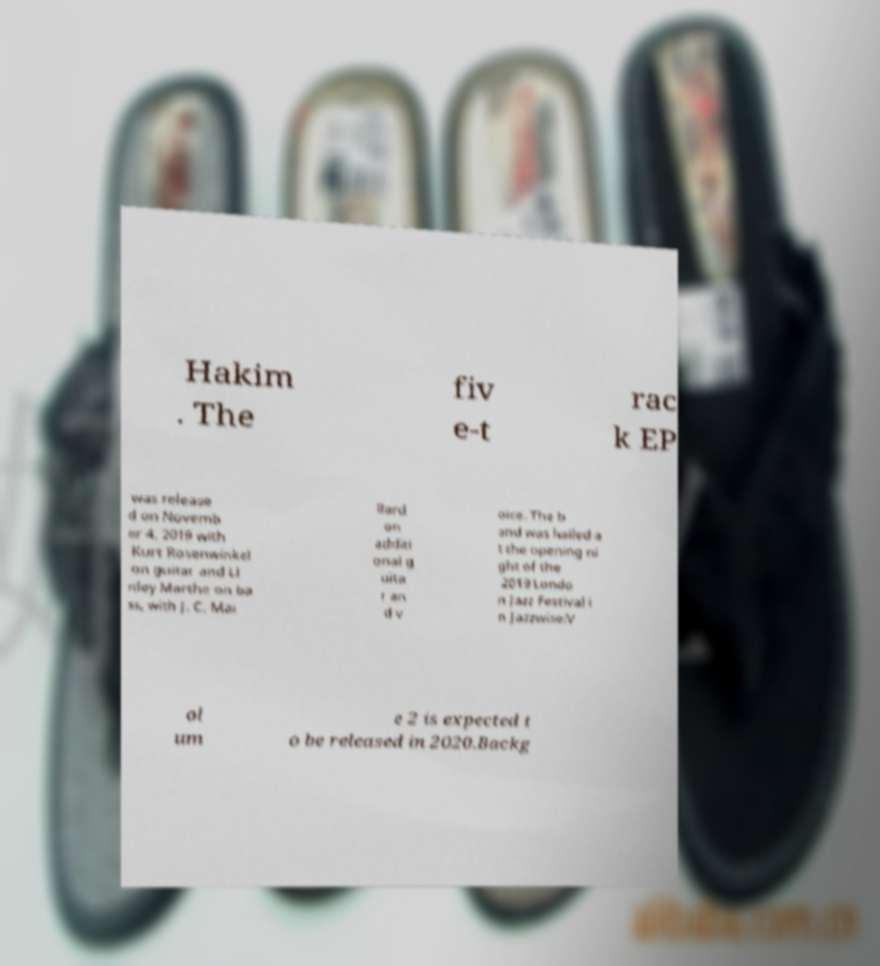I need the written content from this picture converted into text. Can you do that? Hakim . The fiv e-t rac k EP was release d on Novemb er 4, 2019 with Kurt Rosenwinkel on guitar and Li nley Marthe on ba ss, with J. C. Mai llard on additi onal g uita r an d v oice. The b and was hailed a t the opening ni ght of the 2019 Londo n Jazz Festival i n Jazzwise:V ol um e 2 is expected t o be released in 2020.Backg 